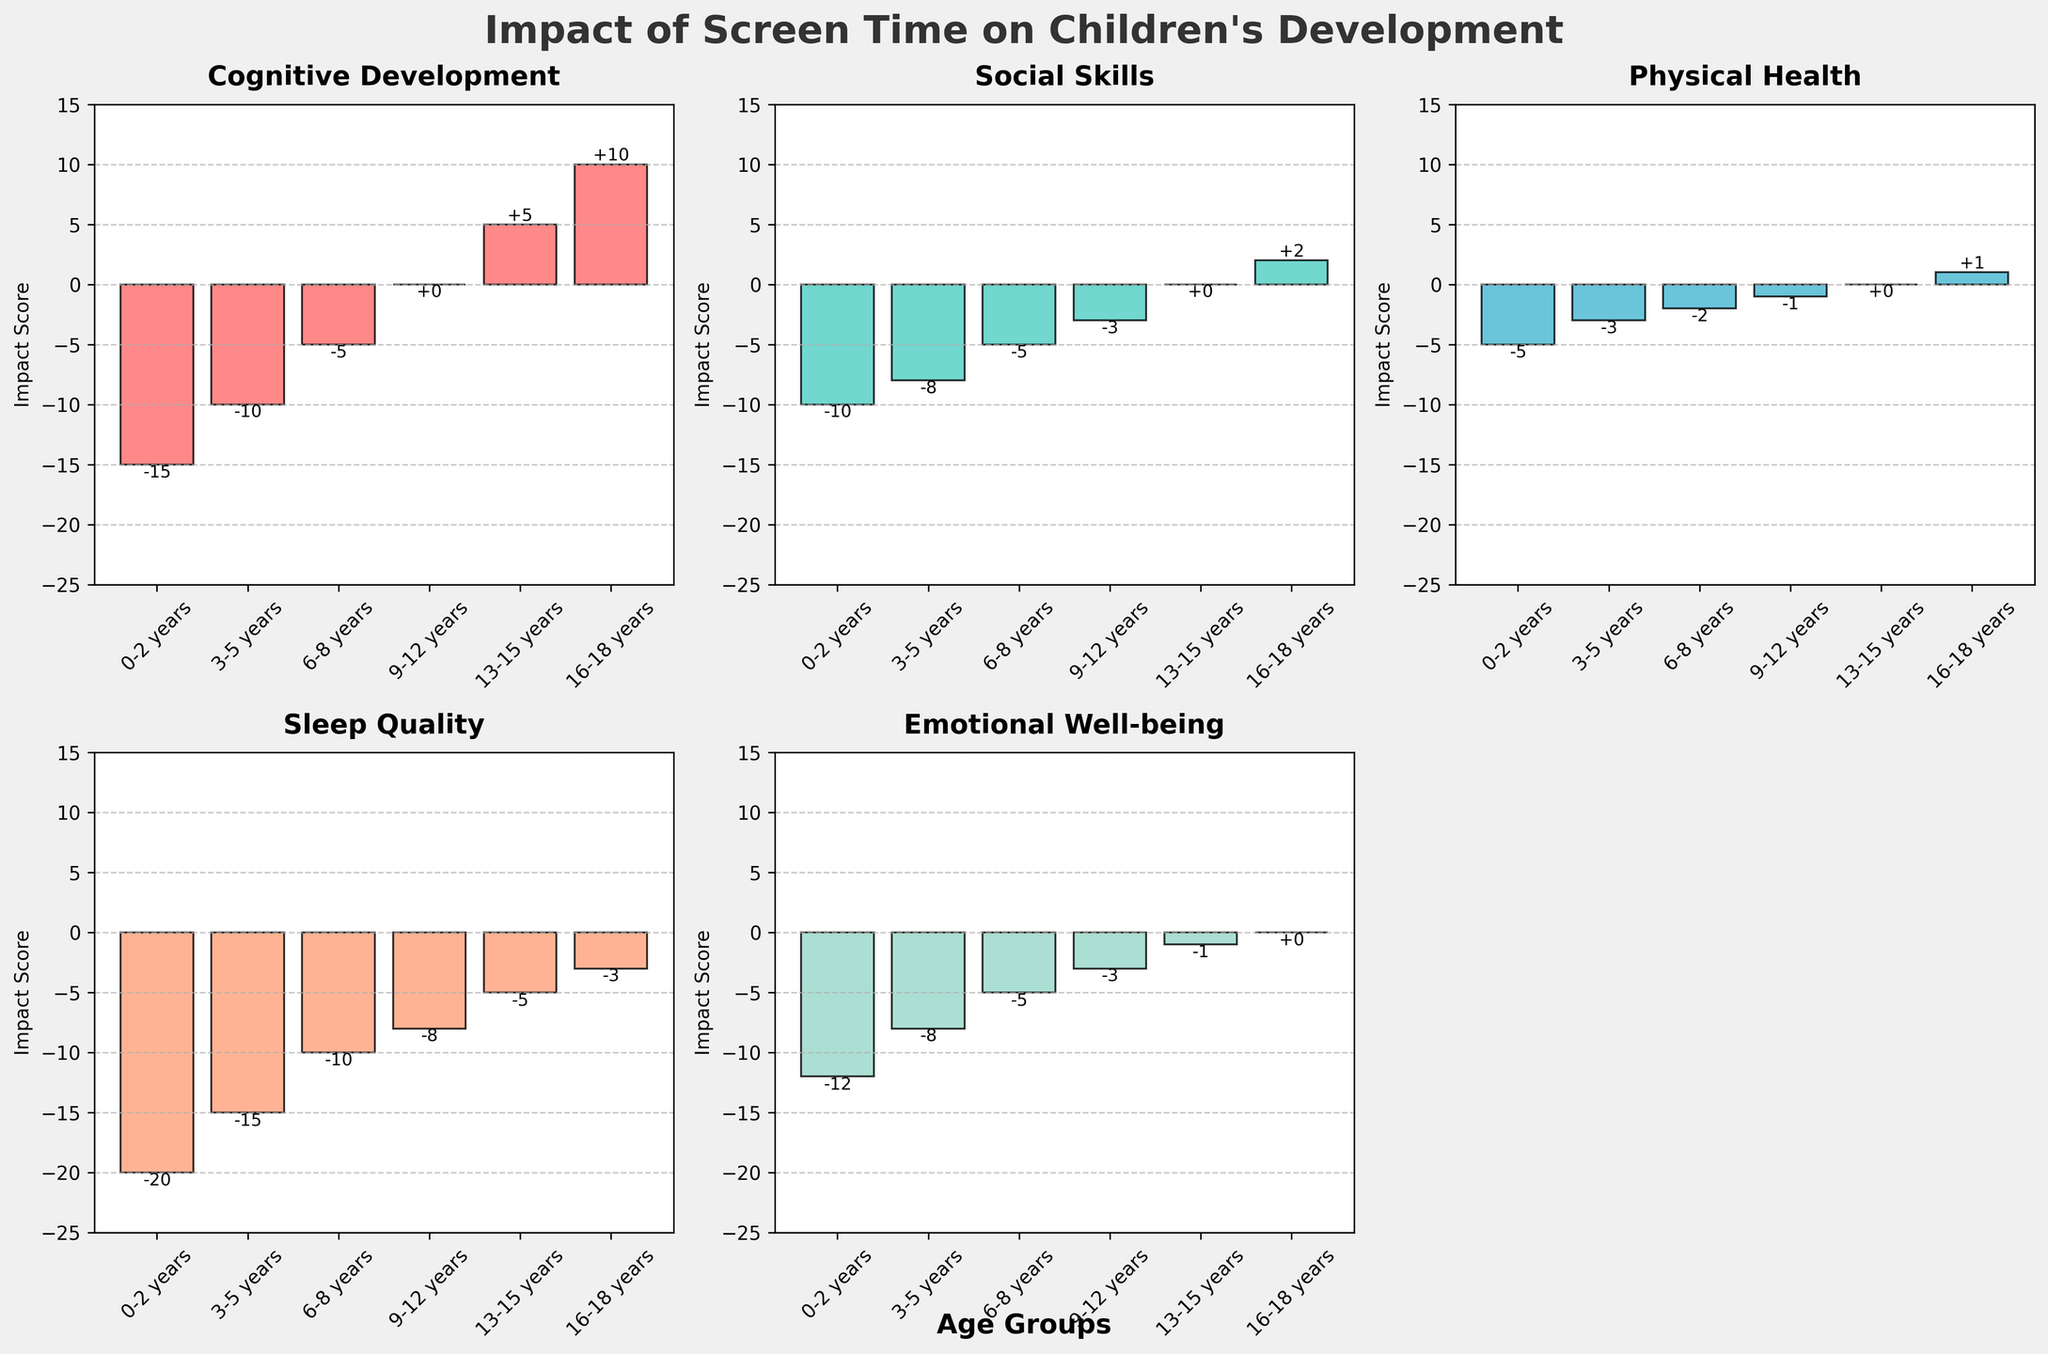What is the title of the figure? The title is usually located at the top of the figure and is written in large, bold font. The title provides a brief description of what the figure represents.
Answer: Impact of Screen Time on Children's Development Which age group shows the most negative impact on Sleep Quality? To find this, locate the subplot titled "Sleep Quality" and identify the bar with the lowest value.
Answer: 0-2 years What is the impact score for Emotional Well-being in the 9-12 years age group? Check the height of the bar corresponding to the 9-12 years age group in the subplot titled "Emotional Well-being".
Answer: -3 How does the Cognitive Development impact score for 16-18 years compare to that for 0-2 years? Locate the bars for both age groups in the "Cognitive Development" subplot and compare their heights. The 16-18 years group has a score of 10, while the 0-2 years group has a score of -15.
Answer: Higher What is the average impact score for Physical Health across all age groups? Sum the values for "Physical Health" across all age groups and divide by the number of age groups (6). The sum is (-5 + -3 + -2 + -1 + 0 + 1 = -10), and the average is -10 / 6.
Answer: -1.67 Which category shows the least negative impact on average across all age groups? Calculate the average impact score for each category by summing the values for each category and dividing by the number of age groups. Compare these averages to find the least negative one.
Answer: Physical Health List the age groups that show a positive impact on Cognitive Development. Identify all the bars with positive heights in the "Cognitive Development" subplot. The age groups are 13-15 years and 16-18 years.
Answer: 13-15 years, 16-18 years What is the overall trend in the impact scores for Social Skills as children age? Examine the heights of the bars in the "Social Skills" subplot from youngest to oldest age groups to identify the trend.
Answer: Increasing In which category does the 3-5 years age group experience the largest negative impact? Identify the lowest bar in the subplot for the 3-5 years age group. The lowest value is -15 in the "Sleep Quality" subplot.
Answer: Sleep Quality How does the Sleep Quality score change from 0-2 years to 16-18 years? Find the values for the 0-2 years age group and the 16-18 years age group in the "Sleep Quality" subplot and calculate the difference. The index changes from -20 to -3.
Answer: Increases by 17 